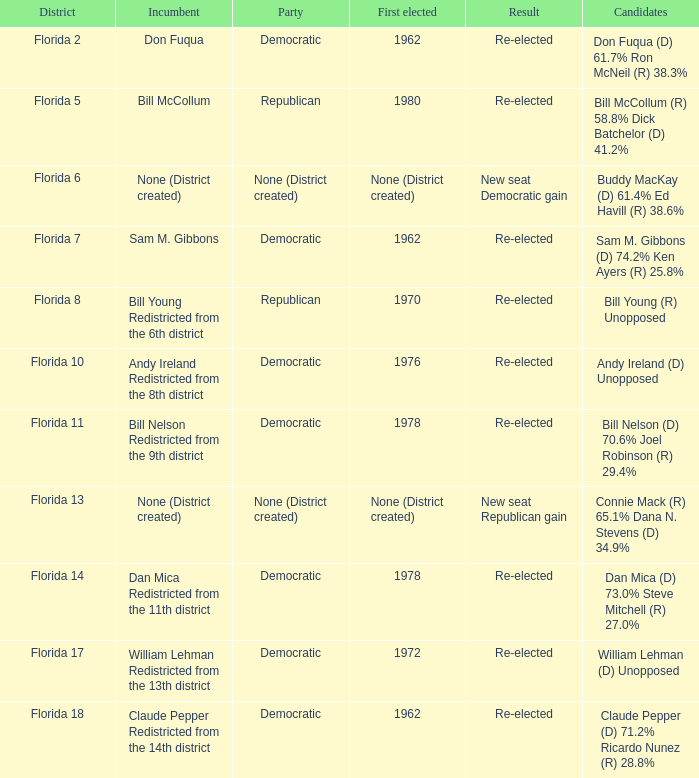What's the result with district being florida 7 Re-elected. 